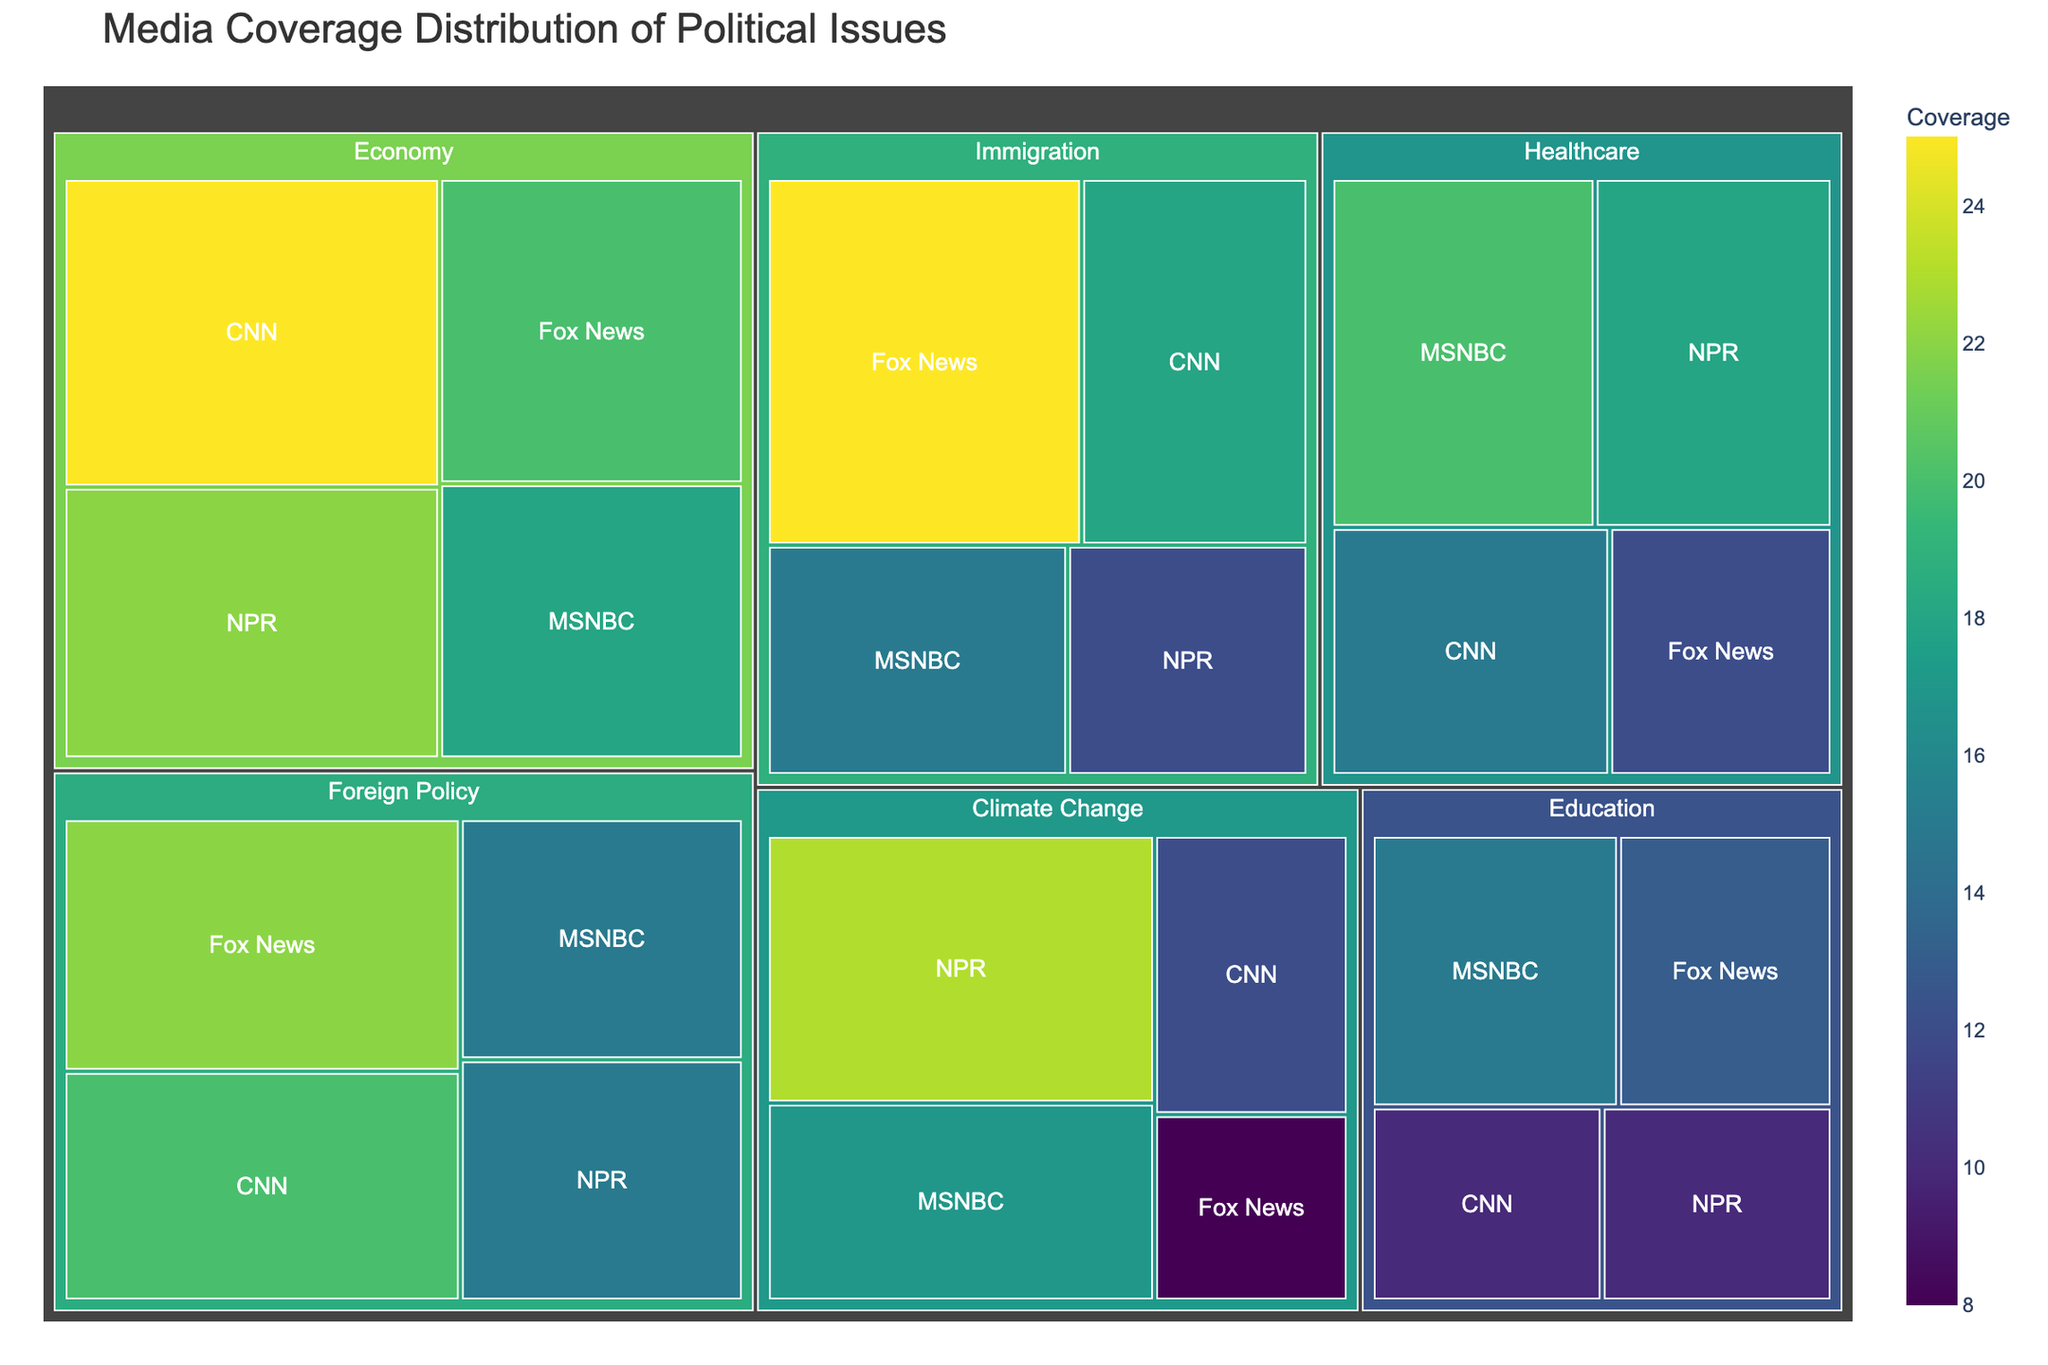What's the title of the figure? The title is the largest and most prominent text in the figure, usually located at the top center. Here the title is "Media Coverage Distribution of Political Issues"
Answer: Media Coverage Distribution of Political Issues Which outlet has the highest coverage for the topic of Immigration? Look for the segment labeled "Immigration" and then within it, find the outlet with the largest area. The largest segment under "Immigration" corresponds to Fox News.
Answer: Fox News What is the total coverage of CNN across all topics? Sum the coverage values of CNN for each topic. (25 for Economy + 15 for Healthcare + 18 for Immigration + 12 for Climate Change + 20 for Foreign Policy + 10 for Education) = 100
Answer: 100 Which outlet has more coverage on Climate Change: MSNBC or NPR? Compare the areas of the MSNBC and NPR segments under the "Climate Change" topic. NPR has a coverage of 23, which is larger than MSNBC's 17.
Answer: NPR What is the smallest coverage value displayed on the figure, and which outlet and topic does it belong to? Identify the smallest segment in the treemap by area and check its label. The smallest area corresponds to Fox News with 8 for Climate Change.
Answer: 8, Fox News, Climate Change Which topic has the largest total coverage across all outlets? Sum up the coverage values for each topic and compare. Economy (25+20+18+22 = 85), Healthcare (15+12+20+18 = 65), Immigration (18+25+15+12 = 70), Climate Change (12+8+17+23 = 60), Foreign Policy (20+22+15+15 = 72), Education (10+13+15+10 = 48). The largest total coverage is for Economy.
Answer: Economy What's the average coverage for Foreign Policy across all outlets? Sum the coverage values for Foreign Policy (20 for CNN + 22 for Fox News + 15 for MSNBC + 15 for NPR = 72) and divide by the number of outlets (4). The average coverage is 72/4 = 18.
Answer: 18 How much more coverage does Fox News have on Immigration compared to NPR on the same topic? Subtract the coverage of NPR from the coverage of Fox News for Immigration. (25 for Fox News - 12 for NPR = 13).
Answer: 13 Which outlet shows the most balanced coverage across different topics? Balance can be measured by the smallest variation in the size of segments across topics. Visually inspecting the segments, CNN appears to have relatively balanced coverage sizes across all topics compared to other outlets.
Answer: CNN 